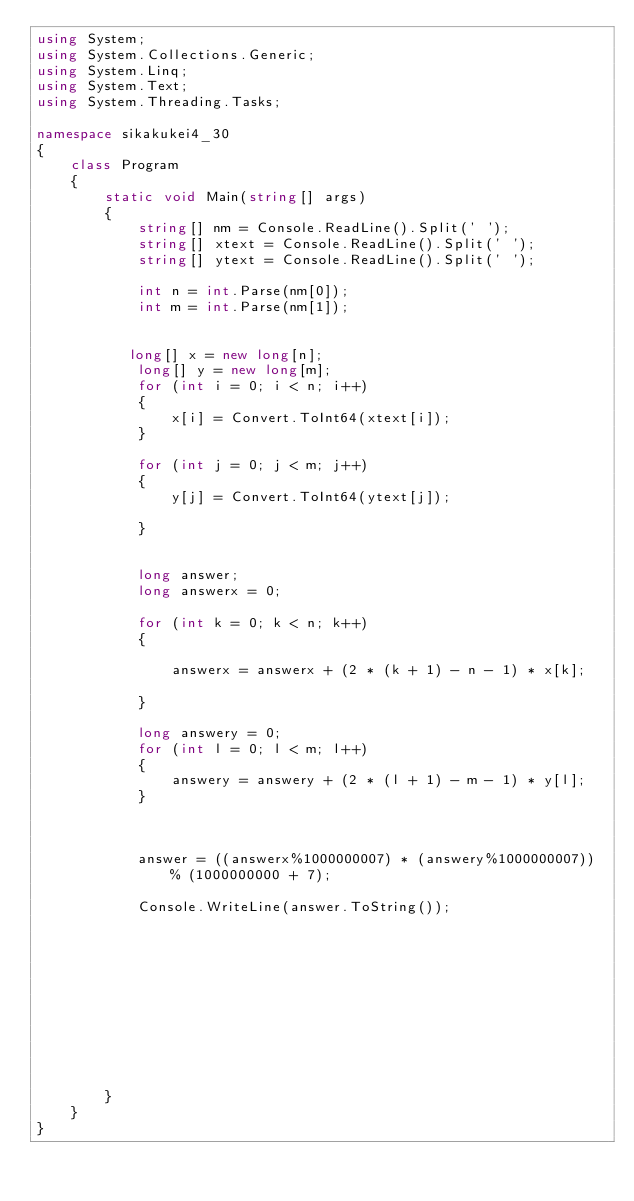Convert code to text. <code><loc_0><loc_0><loc_500><loc_500><_C#_>using System;
using System.Collections.Generic;
using System.Linq;
using System.Text;
using System.Threading.Tasks;

namespace sikakukei4_30
{
    class Program
    {
        static void Main(string[] args)
        {
            string[] nm = Console.ReadLine().Split(' ');
            string[] xtext = Console.ReadLine().Split(' ');
            string[] ytext = Console.ReadLine().Split(' ');

            int n = int.Parse(nm[0]);
            int m = int.Parse(nm[1]);


           long[] x = new long[n];
            long[] y = new long[m];
            for (int i = 0; i < n; i++)
            {
                x[i] = Convert.ToInt64(xtext[i]);
            }

            for (int j = 0; j < m; j++)
            {
                y[j] = Convert.ToInt64(ytext[j]);

            }


            long answer;
            long answerx = 0;

            for (int k = 0; k < n; k++)
            {

                answerx = answerx + (2 * (k + 1) - n - 1) * x[k];
                
            }

            long answery = 0;
            for (int l = 0; l < m; l++)
            {
                answery = answery + (2 * (l + 1) - m - 1) * y[l];
            }



            answer = ((answerx%1000000007) * (answery%1000000007)) % (1000000000 + 7);
           
            Console.WriteLine(answer.ToString());


          

           


           



        }
    }
}</code> 